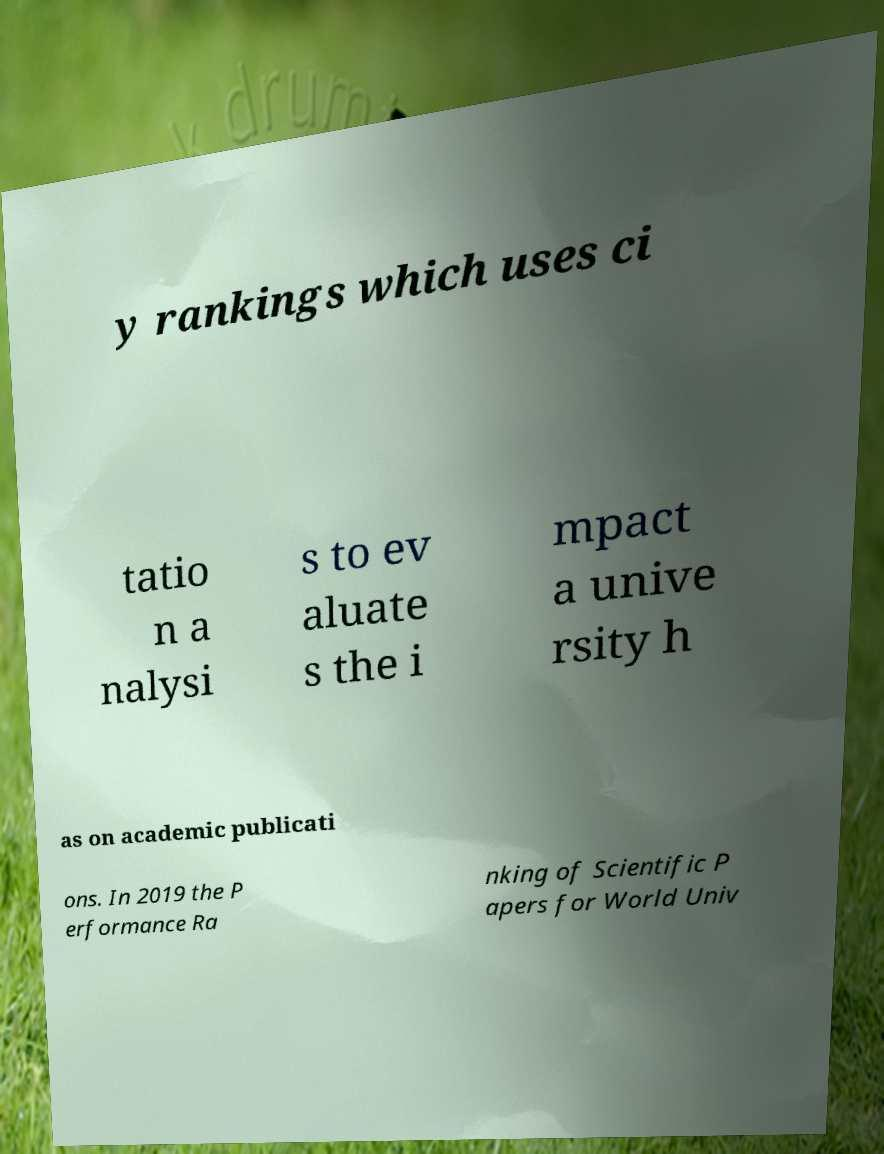Could you extract and type out the text from this image? y rankings which uses ci tatio n a nalysi s to ev aluate s the i mpact a unive rsity h as on academic publicati ons. In 2019 the P erformance Ra nking of Scientific P apers for World Univ 